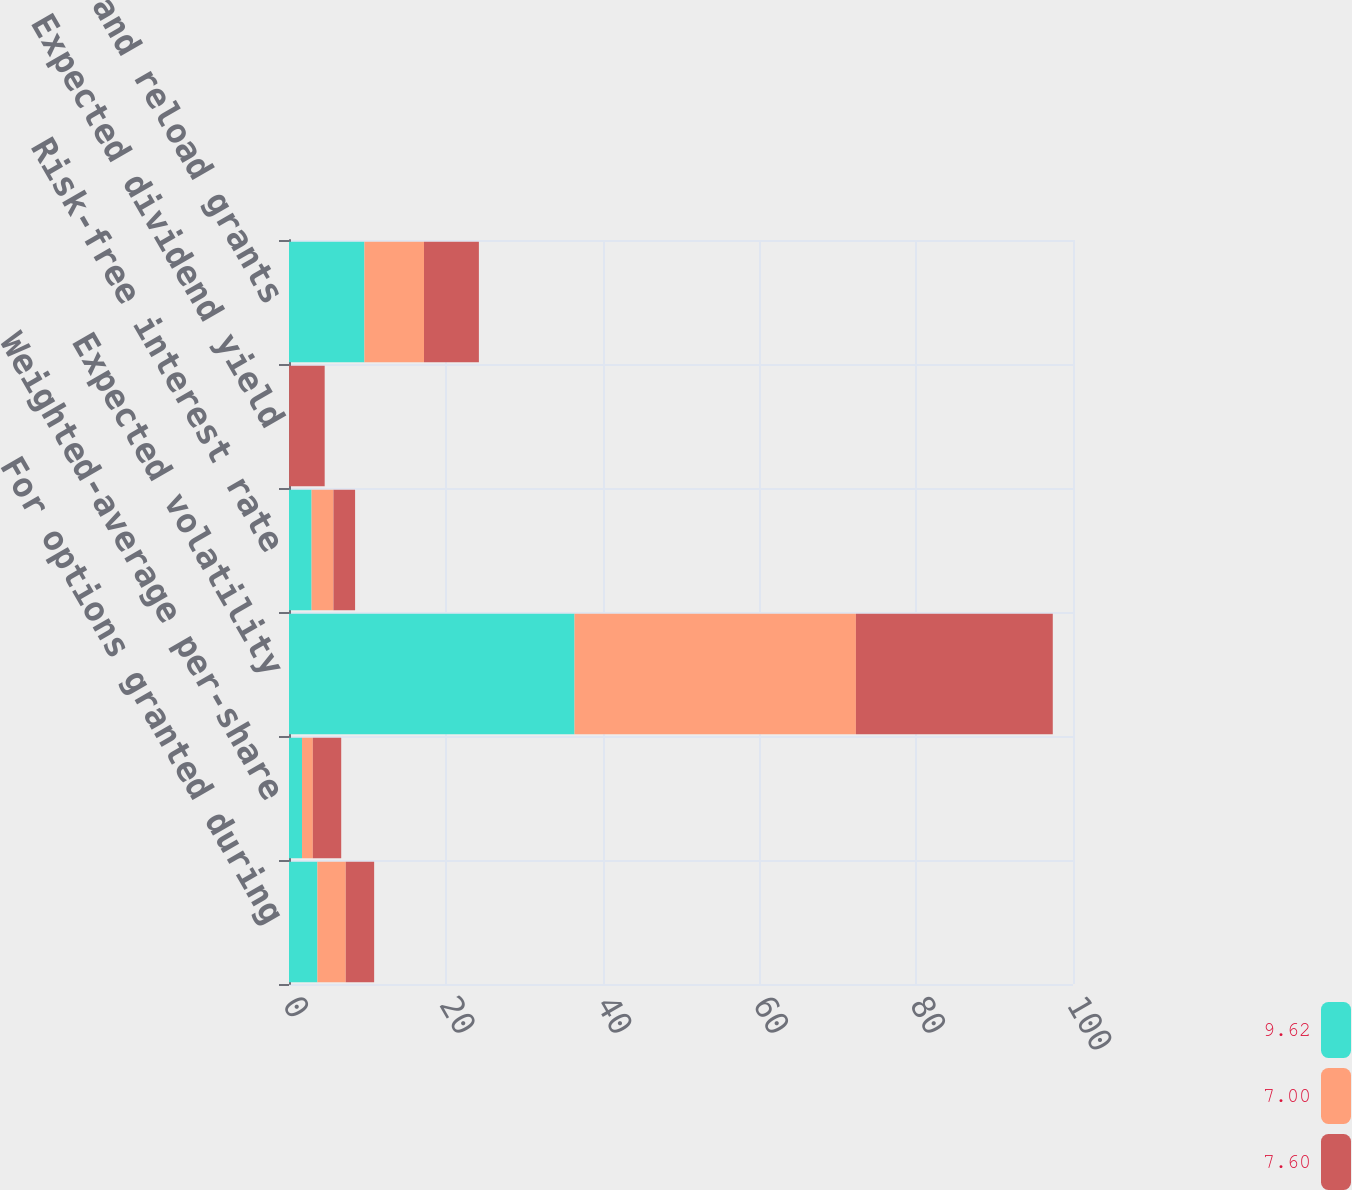Convert chart. <chart><loc_0><loc_0><loc_500><loc_500><stacked_bar_chart><ecel><fcel>For options granted during<fcel>Weighted-average per-share<fcel>Expected volatility<fcel>Risk-free interest rate<fcel>Expected dividend yield<fcel>Original and reload grants<nl><fcel>9.62<fcel>3.62<fcel>1.66<fcel>36.42<fcel>2.88<fcel>0<fcel>9.62<nl><fcel>7<fcel>3.62<fcel>1.38<fcel>35.89<fcel>2.79<fcel>0.02<fcel>7.6<nl><fcel>7.6<fcel>3.62<fcel>3.62<fcel>25.11<fcel>2.76<fcel>4.53<fcel>7<nl></chart> 